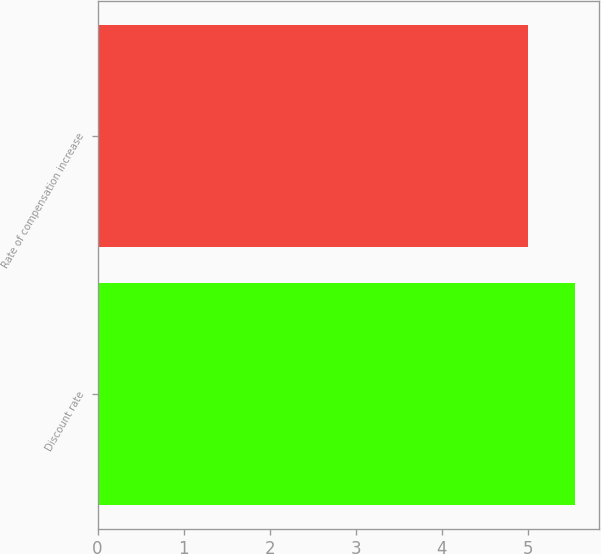Convert chart. <chart><loc_0><loc_0><loc_500><loc_500><bar_chart><fcel>Discount rate<fcel>Rate of compensation increase<nl><fcel>5.55<fcel>5<nl></chart> 